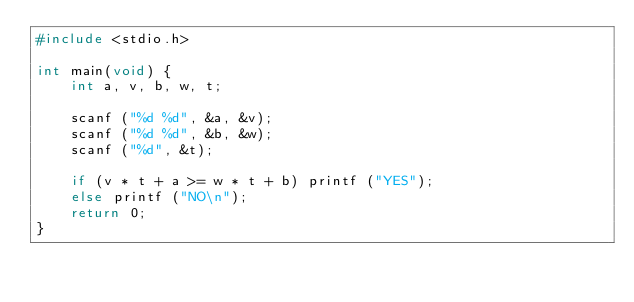<code> <loc_0><loc_0><loc_500><loc_500><_C_>#include <stdio.h>

int main(void) {
    int a, v, b, w, t;

    scanf ("%d %d", &a, &v);
    scanf ("%d %d", &b, &w);
    scanf ("%d", &t);

    if (v * t + a >= w * t + b) printf ("YES");
    else printf ("NO\n");
    return 0;
}</code> 